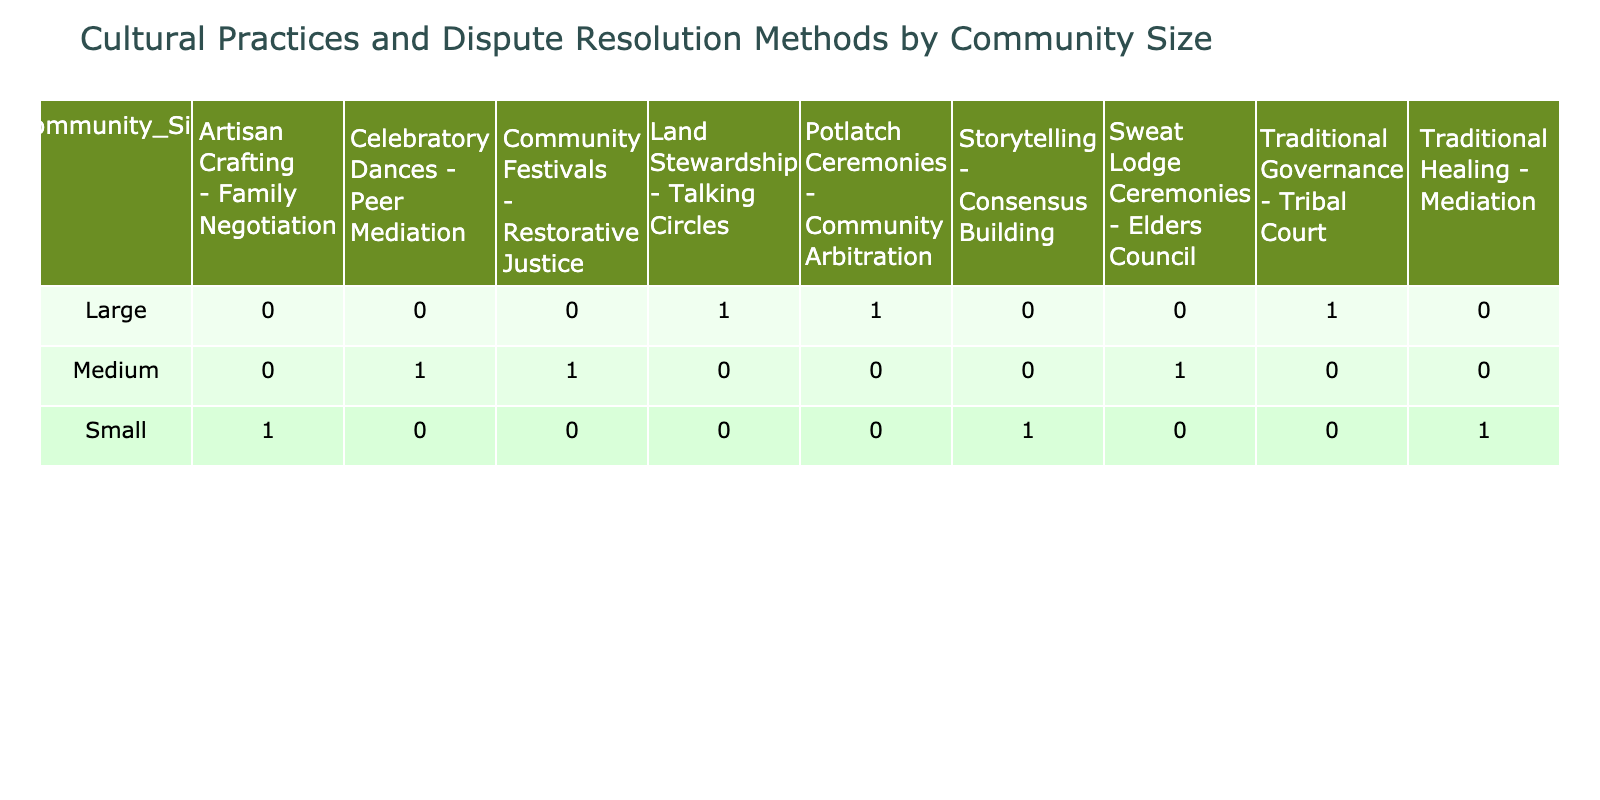What dispute resolution method is associated with the cultural practice of storytelling in small communities? From the table, the cultural practice of storytelling corresponds to the dispute resolution method of consensus building in small communities. This is directly visible in the entry for small community size where storytelling and consensus building are listed together.
Answer: Consensus building How many cultural practices are associated with large communities? By examining the entries for large communities, there are three distinct cultural practices identified: land stewardship, potlatch ceremonies, and traditional governance. Therefore, the total count of cultural practices associated with large communities is three.
Answer: 3 Is mediation used as a dispute resolution method for all community sizes? The table shows that mediation is specifically associated with small communities, linked with the cultural practice of traditional healing. There are no other instances of mediation recorded for medium or large community sizes. Hence, the answer is no, mediation is not used across all sizes.
Answer: No What is the difference in the total number of dispute resolution methods between small and medium communities? Small communities have three dispute resolution methods (consensus building, mediation, and family negotiation). Medium communities have three dispute resolution methods (elders council, peer mediation, and restorative justice). The total number of methods for both sizes is equal, resulting in a difference of zero.
Answer: 0 Which cultural practice has the most associated dispute resolution methods, and in which community size is it found? Among the cultural practices identified, each practice corresponds to only one unique dispute resolution method. Therefore, none of the cultural practices have more than one associated method, resulting in an absence of a practice with multiple methods. Thus there is no clear answer to which practice has the most.
Answer: None 